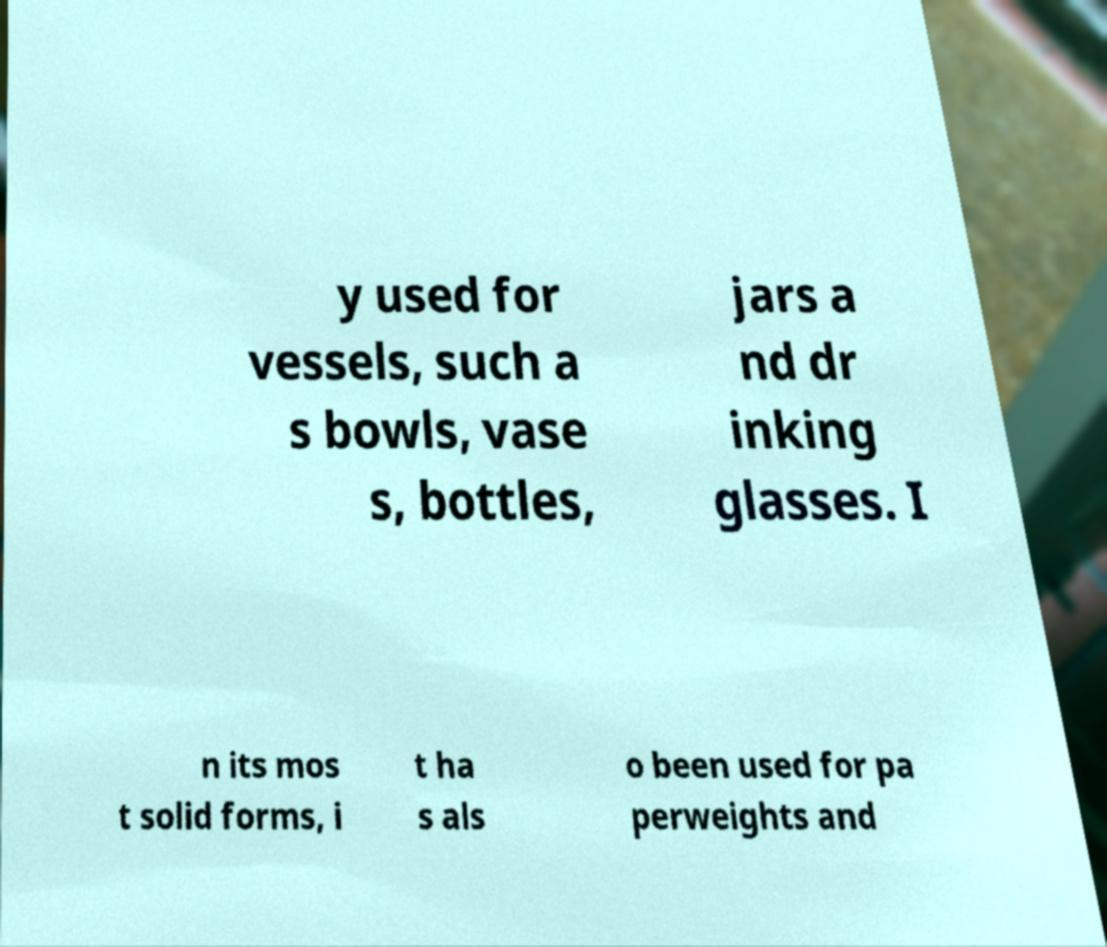Please read and relay the text visible in this image. What does it say? y used for vessels, such a s bowls, vase s, bottles, jars a nd dr inking glasses. I n its mos t solid forms, i t ha s als o been used for pa perweights and 